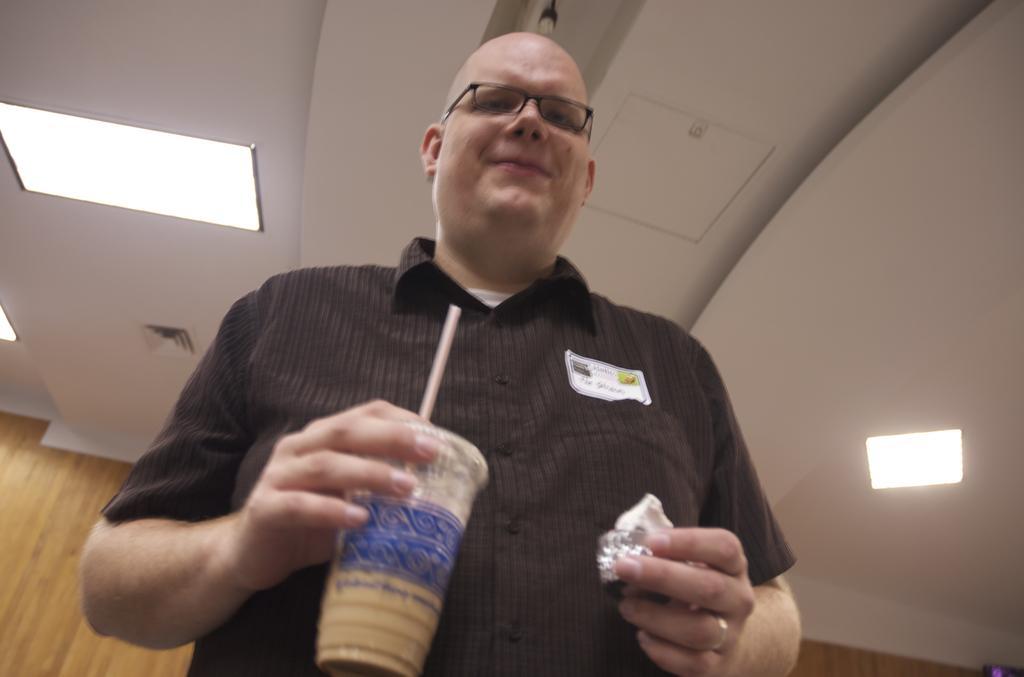Can you describe this image briefly? In this picture I can see a man holding the glass with his hand, at the top there are ceiling lights. 